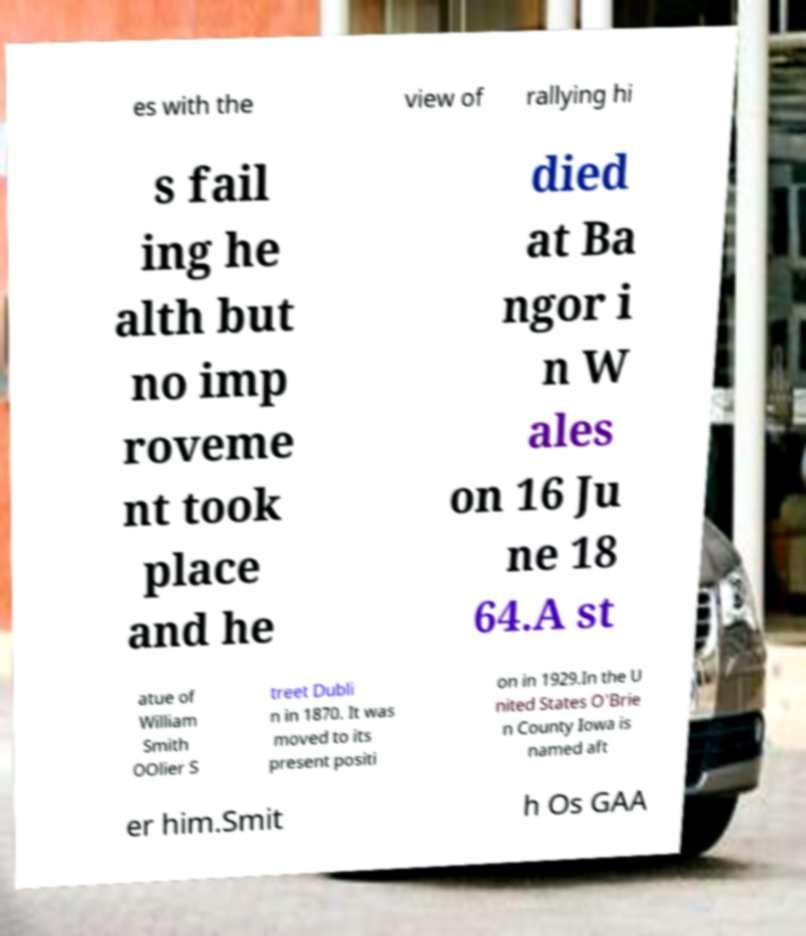I need the written content from this picture converted into text. Can you do that? es with the view of rallying hi s fail ing he alth but no imp roveme nt took place and he died at Ba ngor i n W ales on 16 Ju ne 18 64.A st atue of William Smith OOlier S treet Dubli n in 1870. It was moved to its present positi on in 1929.In the U nited States O'Brie n County Iowa is named aft er him.Smit h Os GAA 